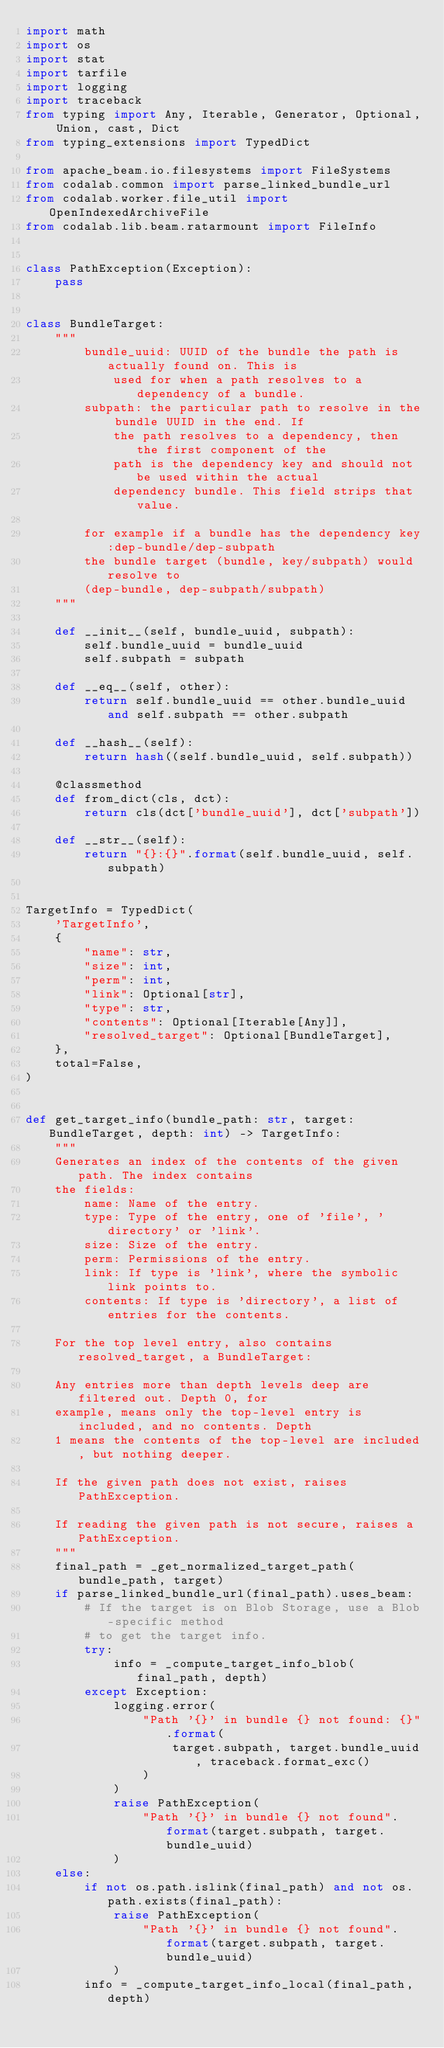Convert code to text. <code><loc_0><loc_0><loc_500><loc_500><_Python_>import math
import os
import stat
import tarfile
import logging
import traceback
from typing import Any, Iterable, Generator, Optional, Union, cast, Dict
from typing_extensions import TypedDict

from apache_beam.io.filesystems import FileSystems
from codalab.common import parse_linked_bundle_url
from codalab.worker.file_util import OpenIndexedArchiveFile
from codalab.lib.beam.ratarmount import FileInfo


class PathException(Exception):
    pass


class BundleTarget:
    """
        bundle_uuid: UUID of the bundle the path is actually found on. This is
            used for when a path resolves to a dependency of a bundle.
        subpath: the particular path to resolve in the bundle UUID in the end. If
            the path resolves to a dependency, then the first component of the
            path is the dependency key and should not be used within the actual
            dependency bundle. This field strips that value.

        for example if a bundle has the dependency key:dep-bundle/dep-subpath
        the bundle target (bundle, key/subpath) would resolve to
        (dep-bundle, dep-subpath/subpath)
    """

    def __init__(self, bundle_uuid, subpath):
        self.bundle_uuid = bundle_uuid
        self.subpath = subpath

    def __eq__(self, other):
        return self.bundle_uuid == other.bundle_uuid and self.subpath == other.subpath

    def __hash__(self):
        return hash((self.bundle_uuid, self.subpath))

    @classmethod
    def from_dict(cls, dct):
        return cls(dct['bundle_uuid'], dct['subpath'])

    def __str__(self):
        return "{}:{}".format(self.bundle_uuid, self.subpath)


TargetInfo = TypedDict(
    'TargetInfo',
    {
        "name": str,
        "size": int,
        "perm": int,
        "link": Optional[str],
        "type": str,
        "contents": Optional[Iterable[Any]],
        "resolved_target": Optional[BundleTarget],
    },
    total=False,
)


def get_target_info(bundle_path: str, target: BundleTarget, depth: int) -> TargetInfo:
    """
    Generates an index of the contents of the given path. The index contains
    the fields:
        name: Name of the entry.
        type: Type of the entry, one of 'file', 'directory' or 'link'.
        size: Size of the entry.
        perm: Permissions of the entry.
        link: If type is 'link', where the symbolic link points to.
        contents: If type is 'directory', a list of entries for the contents.

    For the top level entry, also contains resolved_target, a BundleTarget:

    Any entries more than depth levels deep are filtered out. Depth 0, for
    example, means only the top-level entry is included, and no contents. Depth
    1 means the contents of the top-level are included, but nothing deeper.

    If the given path does not exist, raises PathException.

    If reading the given path is not secure, raises a PathException.
    """
    final_path = _get_normalized_target_path(bundle_path, target)
    if parse_linked_bundle_url(final_path).uses_beam:
        # If the target is on Blob Storage, use a Blob-specific method
        # to get the target info.
        try:
            info = _compute_target_info_blob(final_path, depth)
        except Exception:
            logging.error(
                "Path '{}' in bundle {} not found: {}".format(
                    target.subpath, target.bundle_uuid, traceback.format_exc()
                )
            )
            raise PathException(
                "Path '{}' in bundle {} not found".format(target.subpath, target.bundle_uuid)
            )
    else:
        if not os.path.islink(final_path) and not os.path.exists(final_path):
            raise PathException(
                "Path '{}' in bundle {} not found".format(target.subpath, target.bundle_uuid)
            )
        info = _compute_target_info_local(final_path, depth)
</code> 